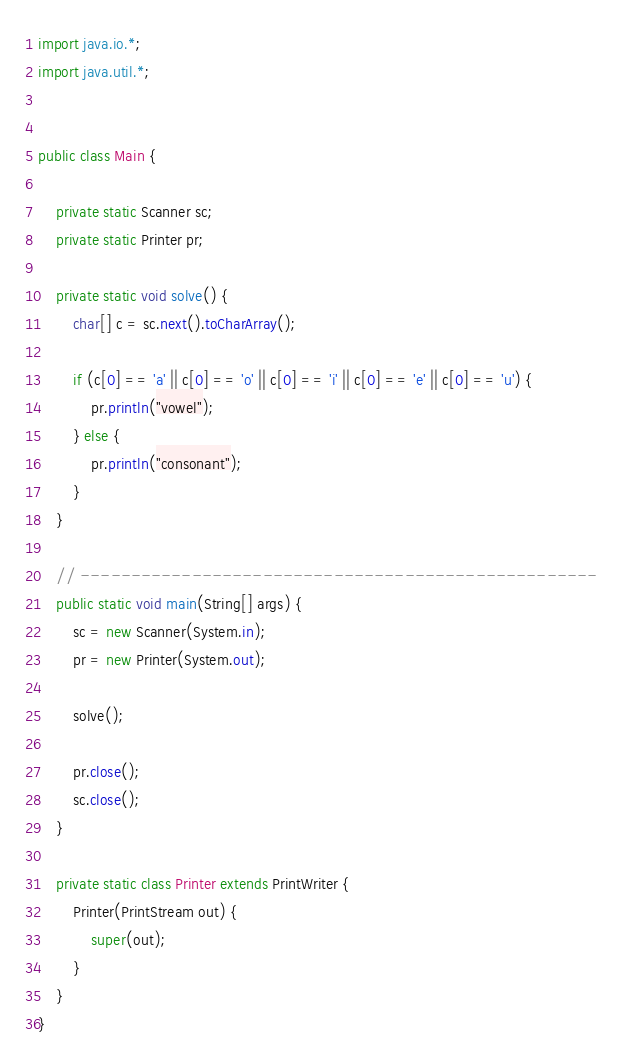<code> <loc_0><loc_0><loc_500><loc_500><_Java_>import java.io.*;
import java.util.*;


public class Main {

	private static Scanner sc;
	private static Printer pr;

	private static void solve() {
		char[] c = sc.next().toCharArray();

		if (c[0] == 'a' || c[0] == 'o' || c[0] == 'i' || c[0] == 'e' || c[0] == 'u') {
			pr.println("vowel");
		} else {
			pr.println("consonant");
		}
	}

	// ---------------------------------------------------
	public static void main(String[] args) {
		sc = new Scanner(System.in);
		pr = new Printer(System.out);

		solve();

		pr.close();
		sc.close();
	}

	private static class Printer extends PrintWriter {
		Printer(PrintStream out) {
			super(out);
		}
	}
}
</code> 